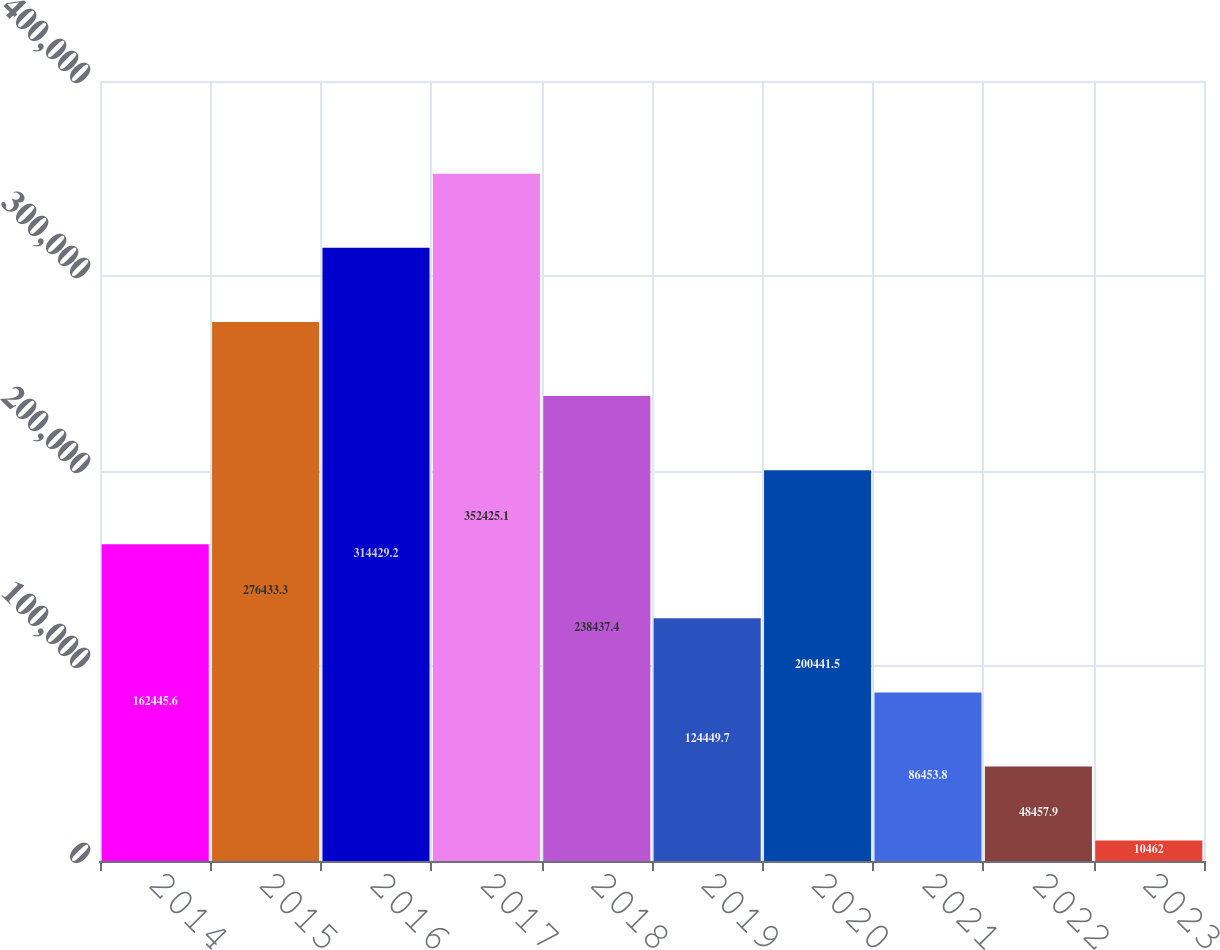Convert chart to OTSL. <chart><loc_0><loc_0><loc_500><loc_500><bar_chart><fcel>2014<fcel>2015<fcel>2016<fcel>2017<fcel>2018<fcel>2019<fcel>2020<fcel>2021<fcel>2022<fcel>2023<nl><fcel>162446<fcel>276433<fcel>314429<fcel>352425<fcel>238437<fcel>124450<fcel>200442<fcel>86453.8<fcel>48457.9<fcel>10462<nl></chart> 